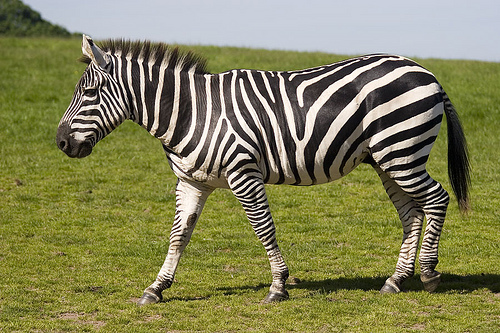<image>What kind of animal is drinking water? I am not sure. There is no animal drinking water or it can be a zebra. What kind of animal is drinking water? I am not sure what kind of animal is drinking water. However, it can be seen that a zebra is drinking water. 